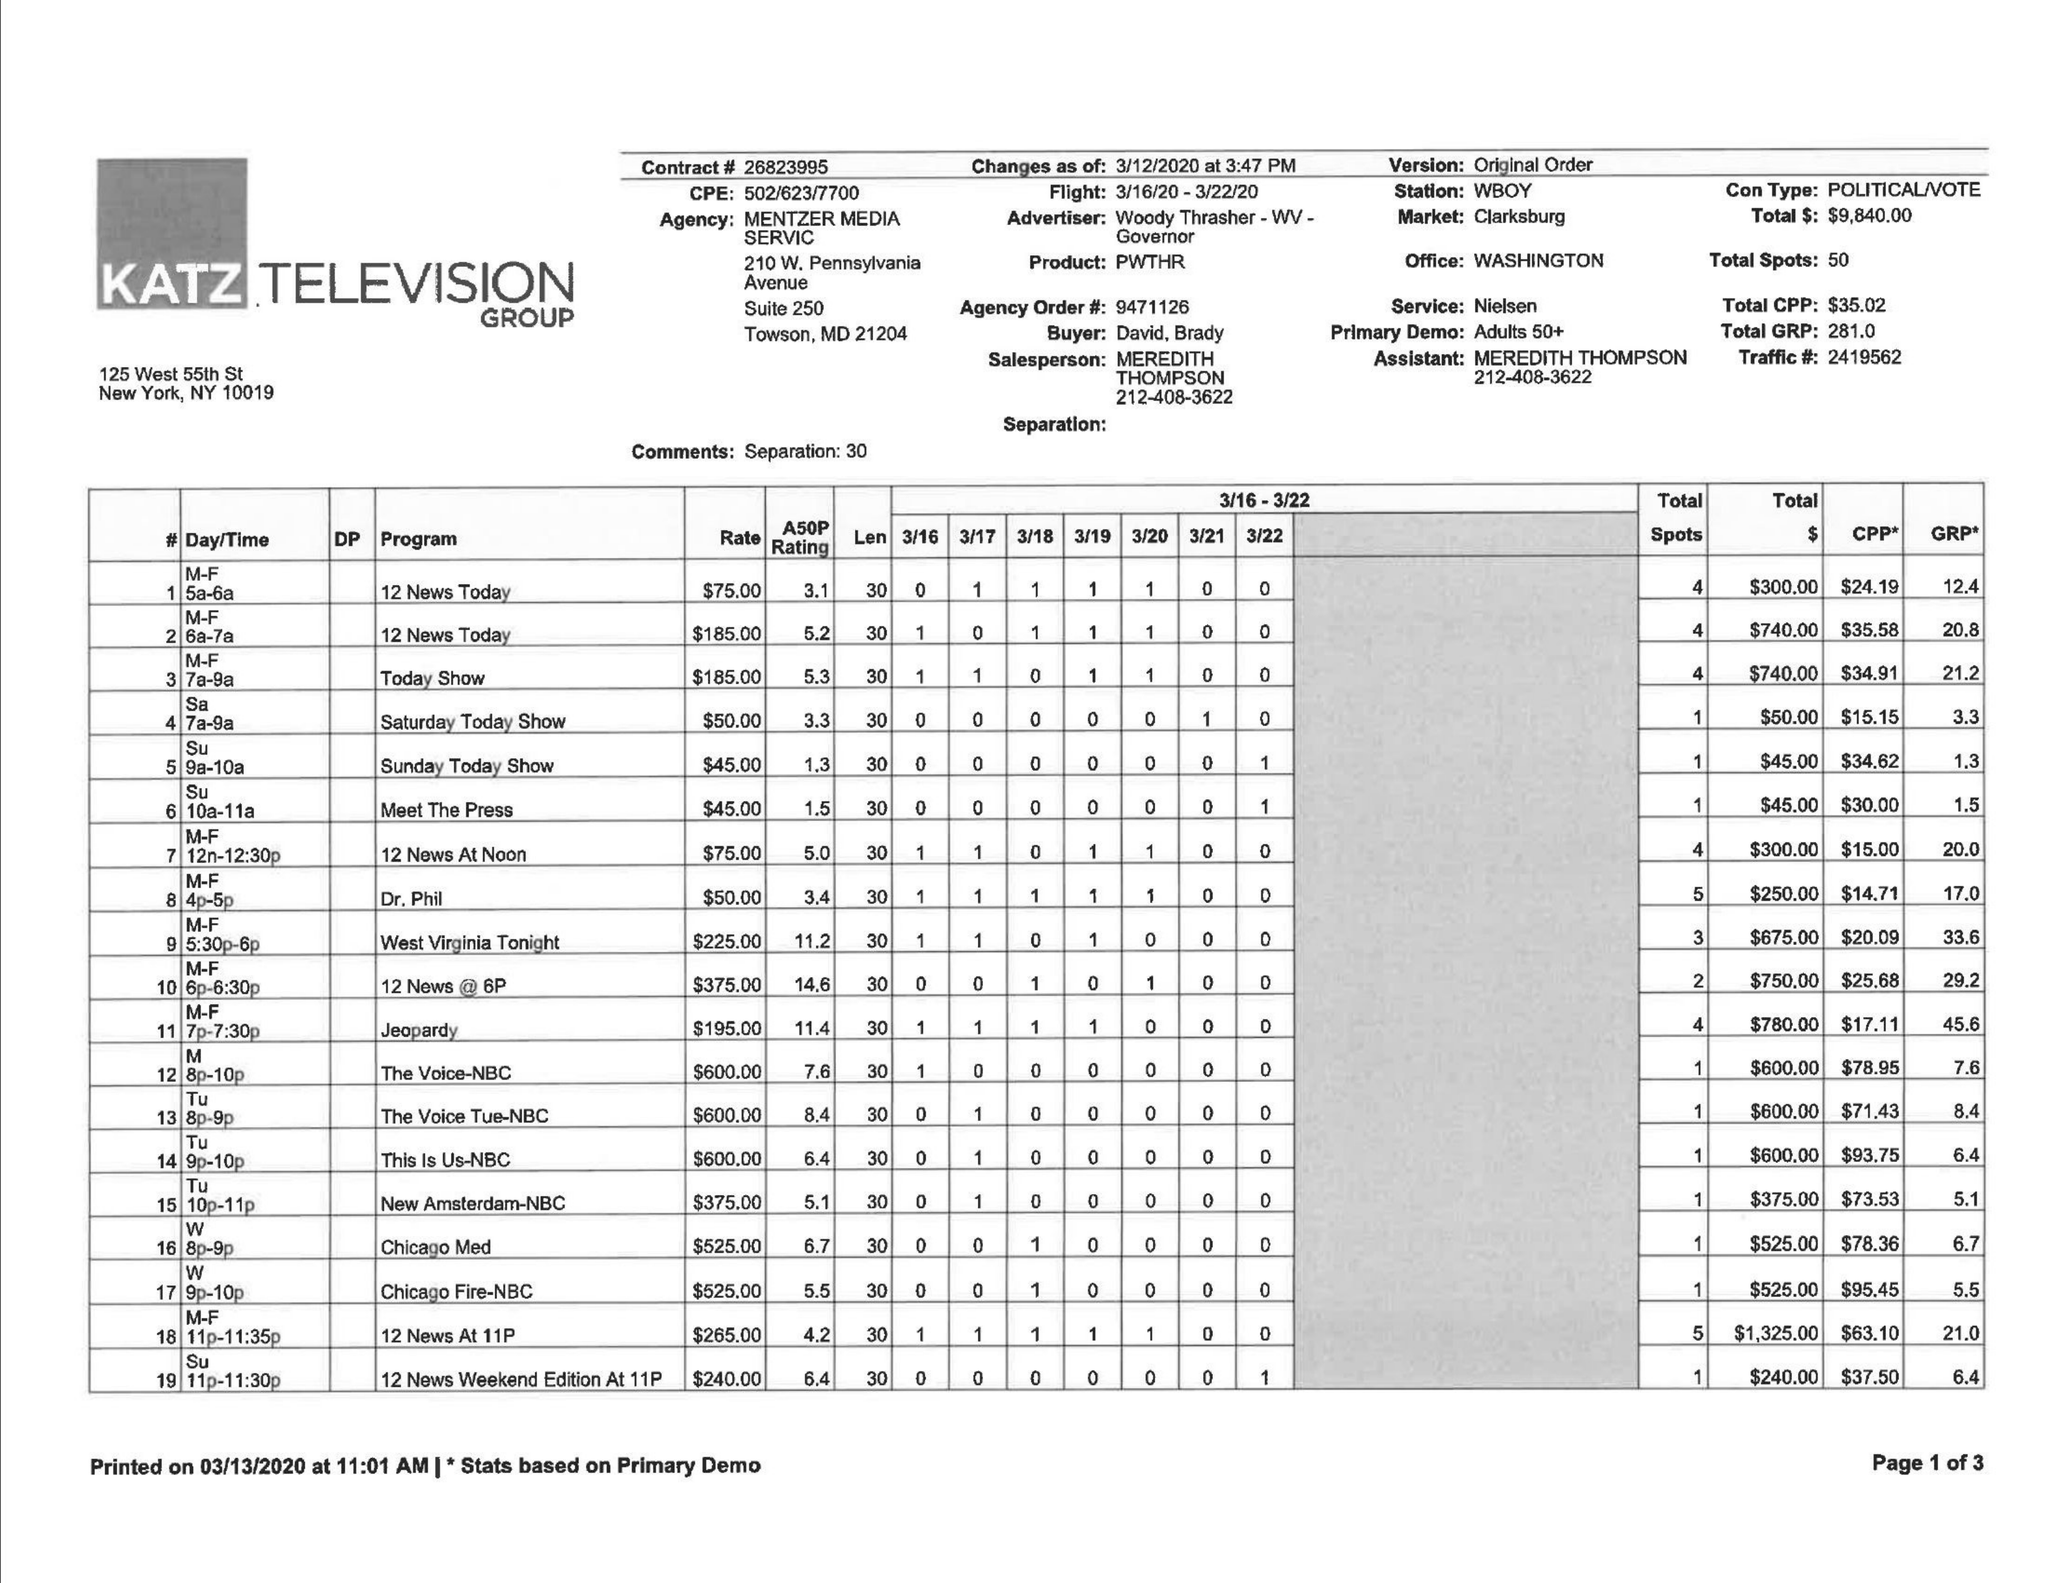What is the value for the flight_from?
Answer the question using a single word or phrase. 03/16/20 